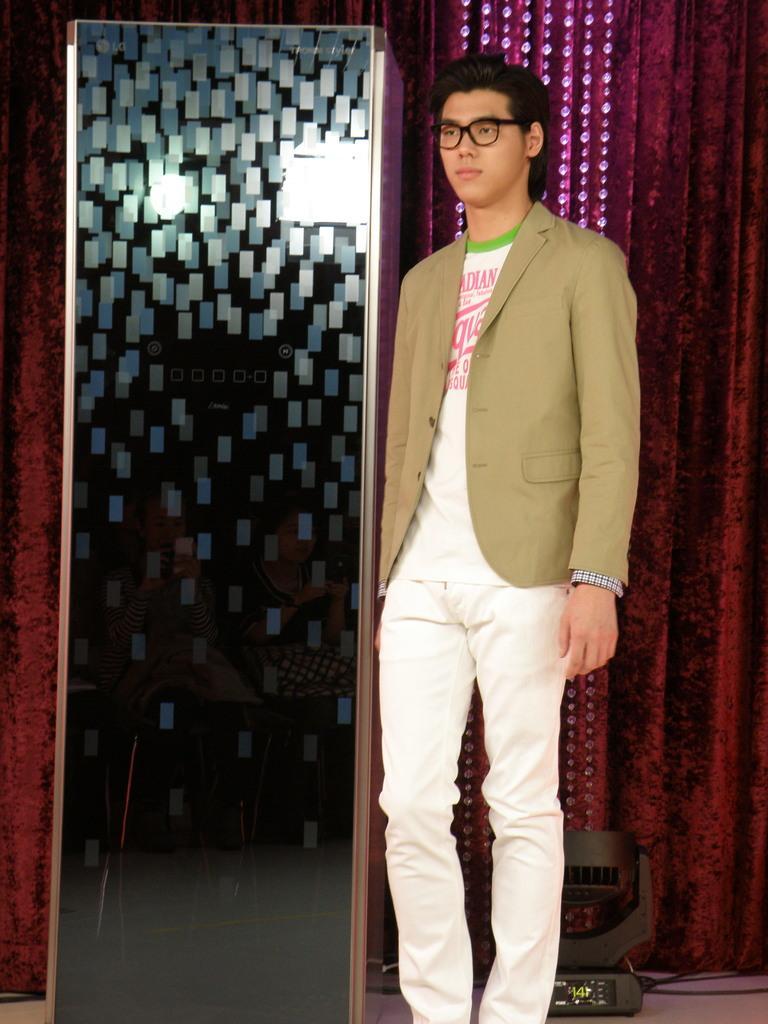Describe this image in one or two sentences. In this image, we can see a person standing and wearing clothes. There is a box on the left and on the right side of the image. There is a light in the bottom right of the image. There is a curtain on the right side of the image. 